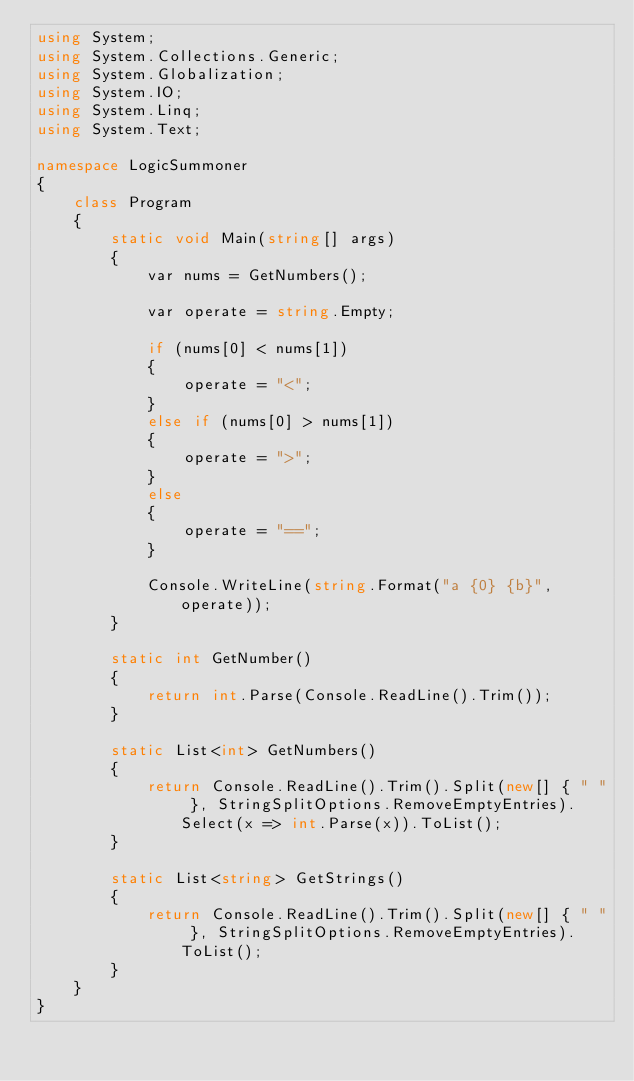<code> <loc_0><loc_0><loc_500><loc_500><_C#_>using System;
using System.Collections.Generic;
using System.Globalization;
using System.IO;
using System.Linq;
using System.Text;

namespace LogicSummoner
{
    class Program
    {
        static void Main(string[] args)
        {
            var nums = GetNumbers();

            var operate = string.Empty;

            if (nums[0] < nums[1])
            {
                operate = "<";
            }
            else if (nums[0] > nums[1])
            {
                operate = ">";
            }
            else
            {
                operate = "==";
            }

            Console.WriteLine(string.Format("a {0} {b}", operate));
        }

        static int GetNumber()
        {
            return int.Parse(Console.ReadLine().Trim());
        }

        static List<int> GetNumbers()
        {
            return Console.ReadLine().Trim().Split(new[] { " " }, StringSplitOptions.RemoveEmptyEntries).Select(x => int.Parse(x)).ToList();
        }

        static List<string> GetStrings()
        {
            return Console.ReadLine().Trim().Split(new[] { " " }, StringSplitOptions.RemoveEmptyEntries).ToList();
        }
    }
}</code> 